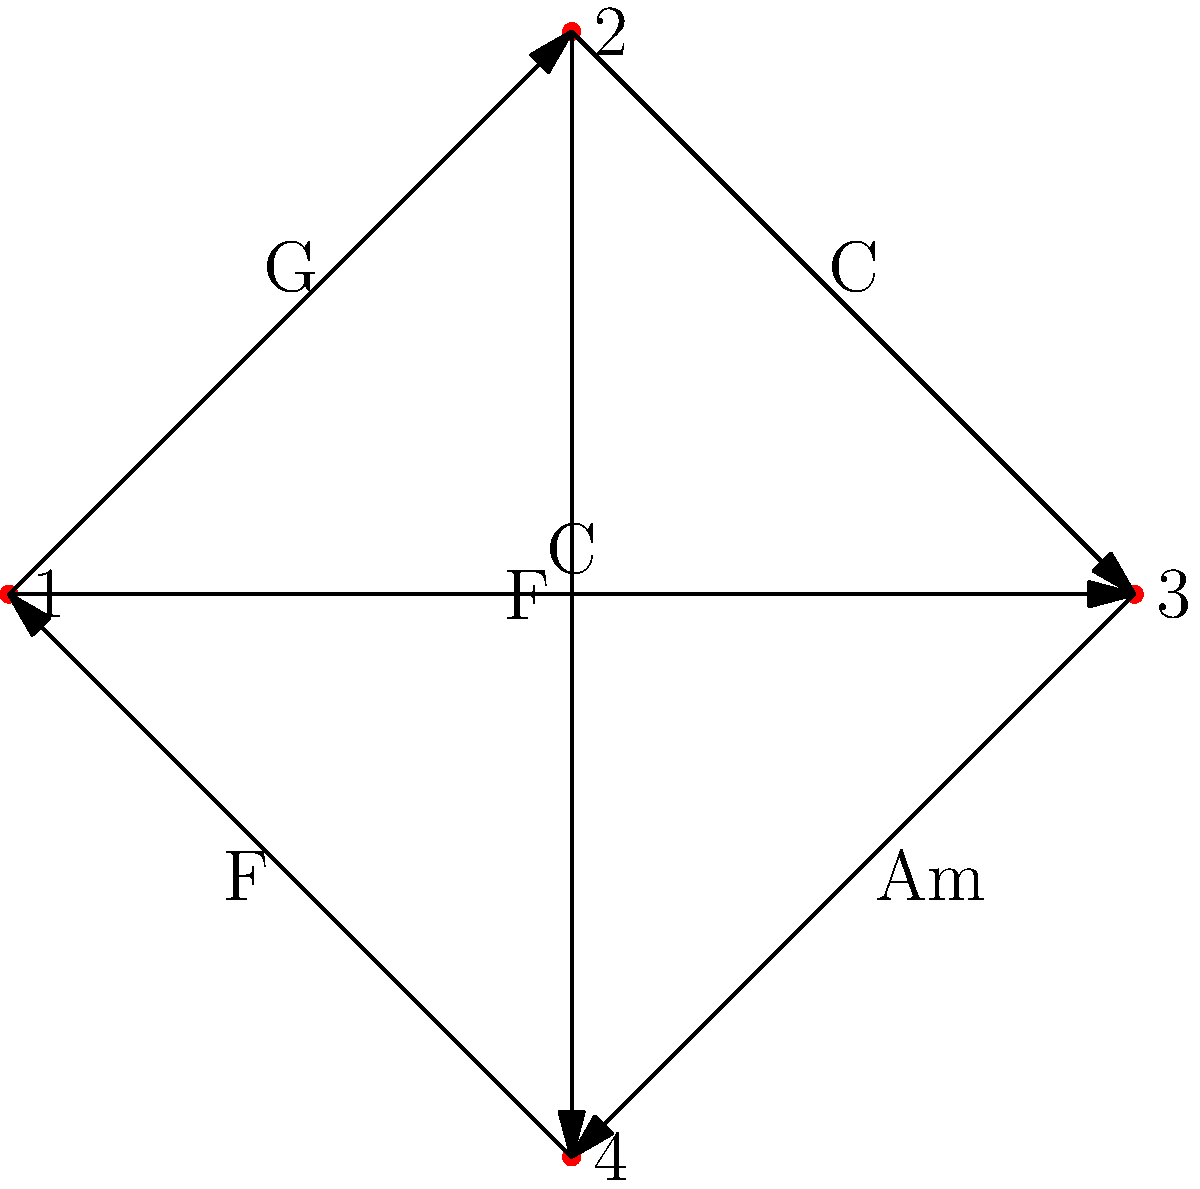Given the directed graph representing chord progressions, where each vertex is a position in the progression and each edge is labeled with a chord, what is the total number of unique 4-chord progressions that start and end with G? To solve this problem, we need to count the number of paths in the graph that:
1. Start at vertex 1 (which represents G)
2. End at vertex 1
3. Contain exactly 4 chords (including the starting and ending G)

Let's break it down step-by-step:

1. We start at vertex 1 (G)
2. From vertex 1, we have two options:
   a. Go to vertex 2 (G → C)
   b. Go to vertex 3 (G → C)
3. For each of these options, we need to find paths that return to vertex 1 in two more steps

For option a (G → C):
- We can go to vertex 3 (C → Am) and then back to 1 (Am → F → G)
- We can go to vertex 4 (C → F) and then back to 1 (F → G)

For option b (G → C):
- We can go to vertex 4 (C → F) and then back to 1 (F → G)

Counting these paths:
1. G → C → Am → F → G
2. G → C → F → G
3. G → C → F → G

Therefore, there are 3 unique 4-chord progressions that start and end with G.
Answer: 3 